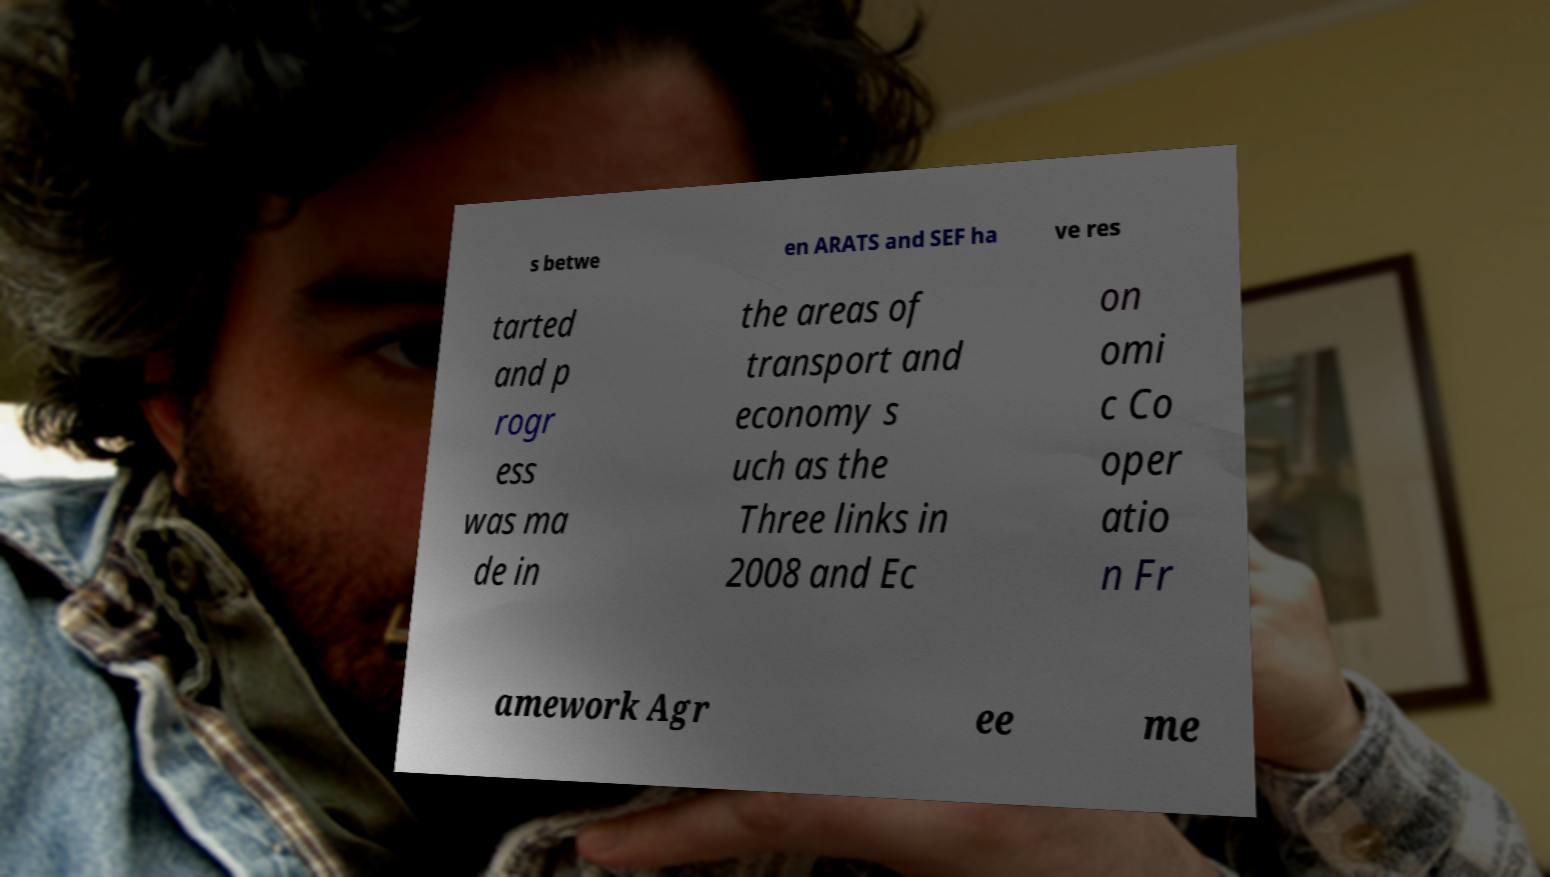There's text embedded in this image that I need extracted. Can you transcribe it verbatim? s betwe en ARATS and SEF ha ve res tarted and p rogr ess was ma de in the areas of transport and economy s uch as the Three links in 2008 and Ec on omi c Co oper atio n Fr amework Agr ee me 